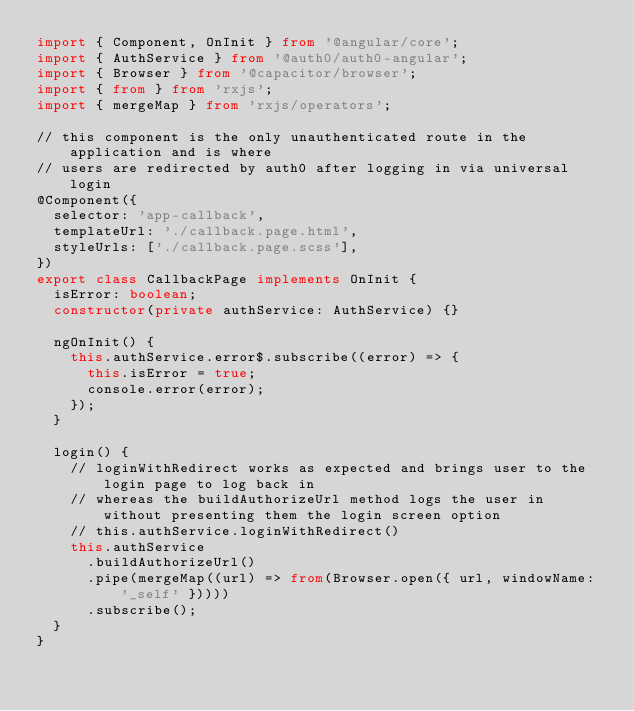<code> <loc_0><loc_0><loc_500><loc_500><_TypeScript_>import { Component, OnInit } from '@angular/core';
import { AuthService } from '@auth0/auth0-angular';
import { Browser } from '@capacitor/browser';
import { from } from 'rxjs';
import { mergeMap } from 'rxjs/operators';

// this component is the only unauthenticated route in the application and is where
// users are redirected by auth0 after logging in via universal login
@Component({
  selector: 'app-callback',
  templateUrl: './callback.page.html',
  styleUrls: ['./callback.page.scss'],
})
export class CallbackPage implements OnInit {
  isError: boolean;
  constructor(private authService: AuthService) {}

  ngOnInit() {
    this.authService.error$.subscribe((error) => {
      this.isError = true;
      console.error(error);
    });
  }

  login() {
    // loginWithRedirect works as expected and brings user to the login page to log back in
    // whereas the buildAuthorizeUrl method logs the user in without presenting them the login screen option
    // this.authService.loginWithRedirect()
    this.authService
      .buildAuthorizeUrl()
      .pipe(mergeMap((url) => from(Browser.open({ url, windowName: '_self' }))))
      .subscribe();
  }
}
</code> 